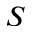Convert formula to latex. <formula><loc_0><loc_0><loc_500><loc_500>S</formula> 